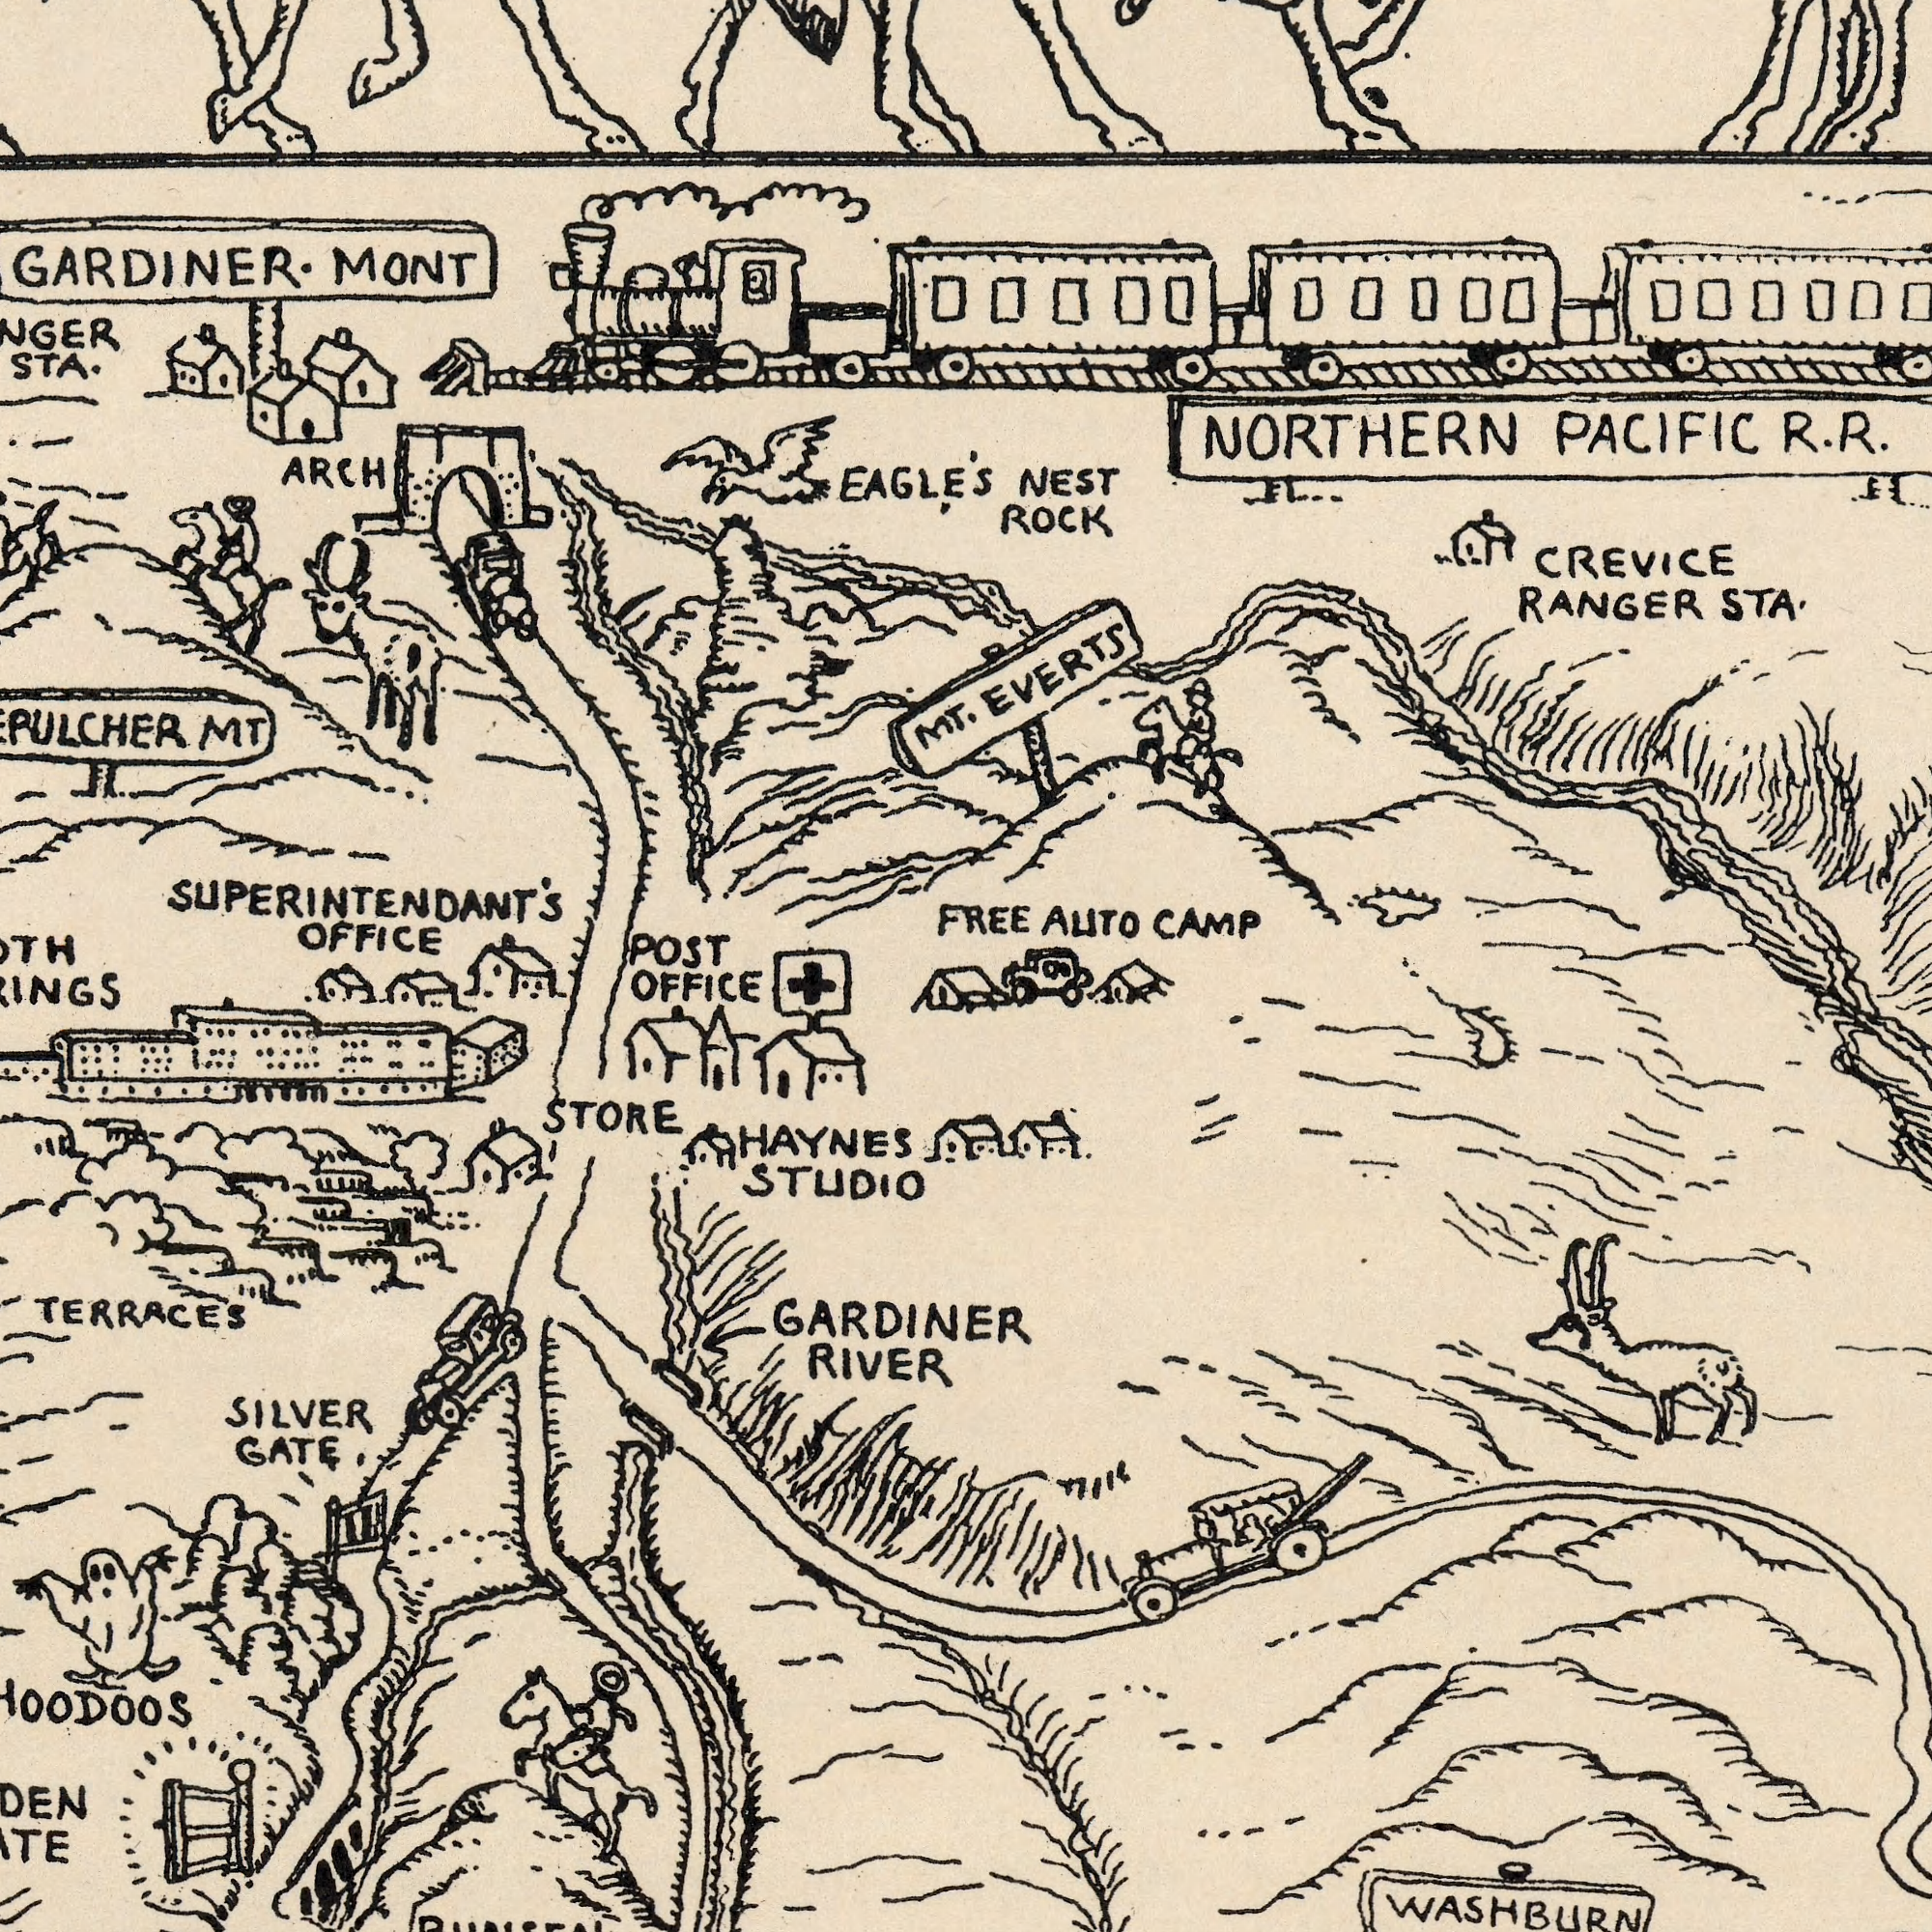What text can you see in the top-right section? CREVICE RANGER ROCK EVERTS NEST CAMP AUTO NORTHERN STA. R. FREE PACIFIC R. What text is visible in the lower-left corner? TERRACES STORE STUDIO GARDINER SILVER RIVER GATE HAYNES What text is visible in the upper-left corner? MONT OFFICE STA. EAGLE'S ARCH POST MT MT. SUPERINTENDANT'S OFFICE What text can you see in the bottom-right section? WASHBURN 